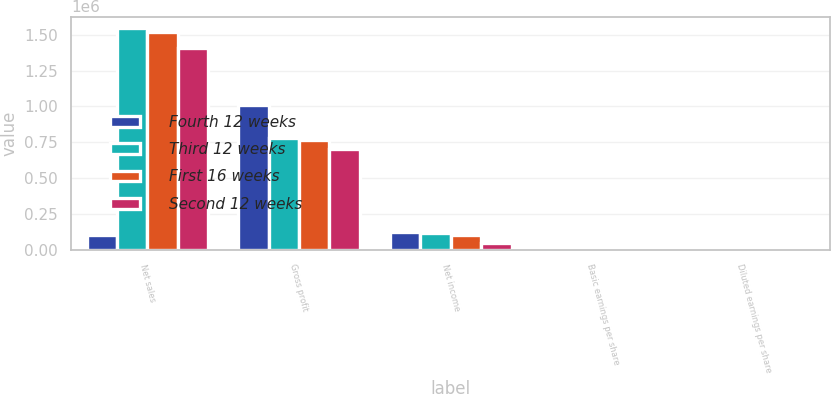Convert chart. <chart><loc_0><loc_0><loc_500><loc_500><stacked_bar_chart><ecel><fcel>Net sales<fcel>Gross profit<fcel>Net income<fcel>Basic earnings per share<fcel>Diluted earnings per share<nl><fcel>Fourth 12 weeks<fcel>103830<fcel>1.00821e+06<fcel>121790<fcel>1.66<fcel>1.65<nl><fcel>Third 12 weeks<fcel>1.54955e+06<fcel>779223<fcel>116871<fcel>1.6<fcel>1.59<nl><fcel>First 16 weeks<fcel>1.52014e+06<fcel>762940<fcel>103830<fcel>1.42<fcel>1.42<nl><fcel>Second 12 weeks<fcel>1.40881e+06<fcel>701777<fcel>49267<fcel>0.68<fcel>0.67<nl></chart> 